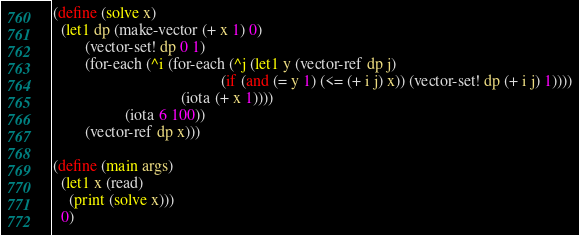<code> <loc_0><loc_0><loc_500><loc_500><_Scheme_>(define (solve x)
  (let1 dp (make-vector (+ x 1) 0)
        (vector-set! dp 0 1)
        (for-each (^i (for-each (^j (let1 y (vector-ref dp j)
                                          (if (and (= y 1) (<= (+ i j) x)) (vector-set! dp (+ i j) 1))))
                                (iota (+ x 1))))
                  (iota 6 100))
        (vector-ref dp x)))

(define (main args)
  (let1 x (read)
    (print (solve x)))
  0)
</code> 